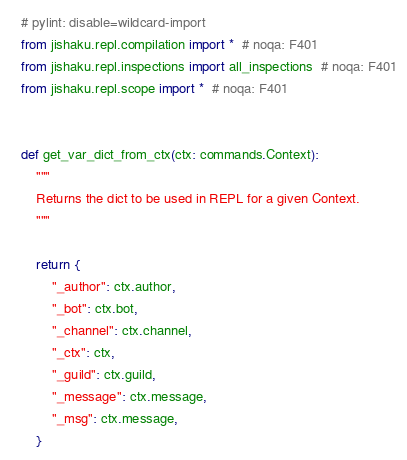<code> <loc_0><loc_0><loc_500><loc_500><_Python_>
# pylint: disable=wildcard-import
from jishaku.repl.compilation import *  # noqa: F401
from jishaku.repl.inspections import all_inspections  # noqa: F401
from jishaku.repl.scope import *  # noqa: F401


def get_var_dict_from_ctx(ctx: commands.Context):
    """
    Returns the dict to be used in REPL for a given Context.
    """

    return {
        "_author": ctx.author,
        "_bot": ctx.bot,
        "_channel": ctx.channel,
        "_ctx": ctx,
        "_guild": ctx.guild,
        "_message": ctx.message,
        "_msg": ctx.message,
    }
</code> 